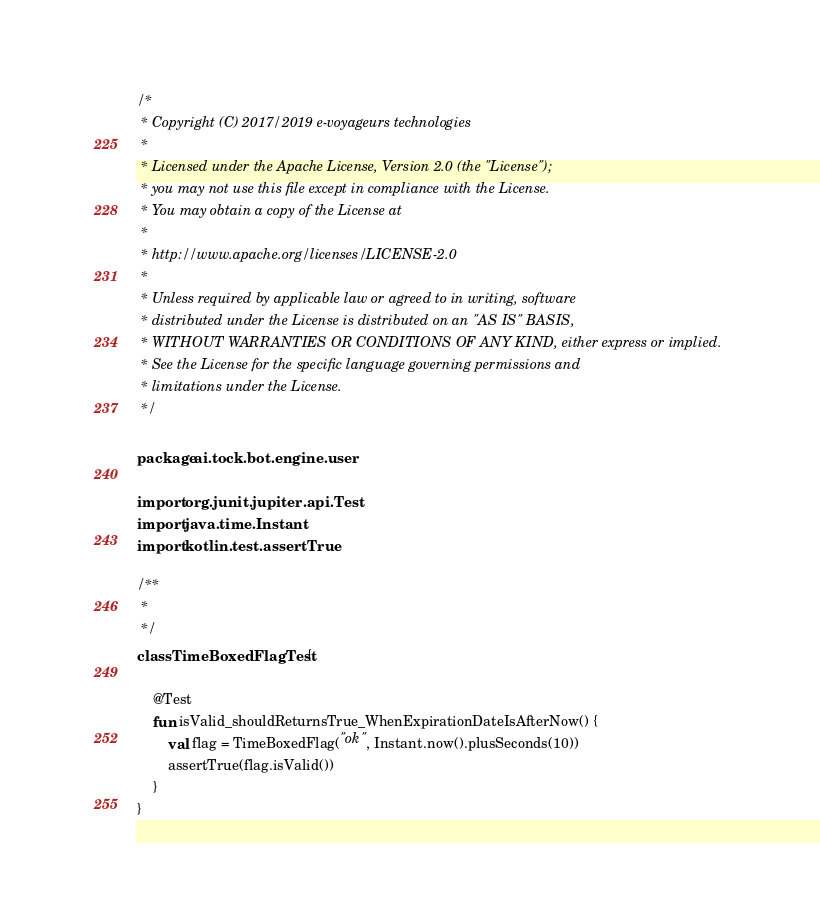Convert code to text. <code><loc_0><loc_0><loc_500><loc_500><_Kotlin_>/*
 * Copyright (C) 2017/2019 e-voyageurs technologies
 *
 * Licensed under the Apache License, Version 2.0 (the "License");
 * you may not use this file except in compliance with the License.
 * You may obtain a copy of the License at
 *
 * http://www.apache.org/licenses/LICENSE-2.0
 *
 * Unless required by applicable law or agreed to in writing, software
 * distributed under the License is distributed on an "AS IS" BASIS,
 * WITHOUT WARRANTIES OR CONDITIONS OF ANY KIND, either express or implied.
 * See the License for the specific language governing permissions and
 * limitations under the License.
 */

package ai.tock.bot.engine.user

import org.junit.jupiter.api.Test
import java.time.Instant
import kotlin.test.assertTrue

/**
 *
 */
class TimeBoxedFlagTest {

    @Test
    fun isValid_shouldReturnsTrue_WhenExpirationDateIsAfterNow() {
        val flag = TimeBoxedFlag("ok", Instant.now().plusSeconds(10))
        assertTrue(flag.isValid())
    }
}</code> 